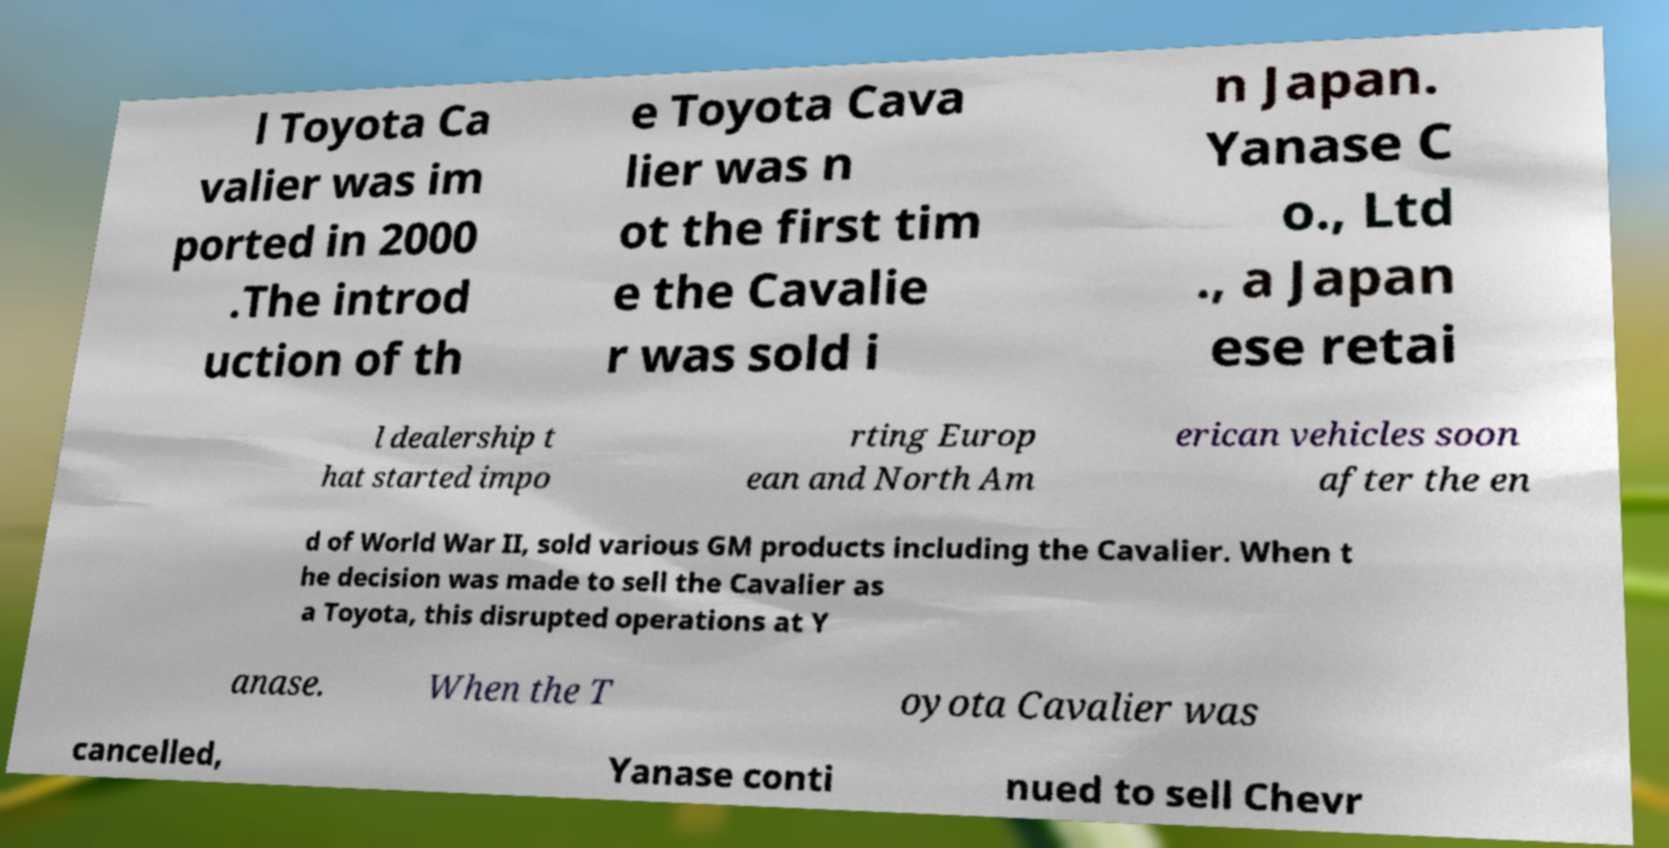There's text embedded in this image that I need extracted. Can you transcribe it verbatim? l Toyota Ca valier was im ported in 2000 .The introd uction of th e Toyota Cava lier was n ot the first tim e the Cavalie r was sold i n Japan. Yanase C o., Ltd ., a Japan ese retai l dealership t hat started impo rting Europ ean and North Am erican vehicles soon after the en d of World War II, sold various GM products including the Cavalier. When t he decision was made to sell the Cavalier as a Toyota, this disrupted operations at Y anase. When the T oyota Cavalier was cancelled, Yanase conti nued to sell Chevr 